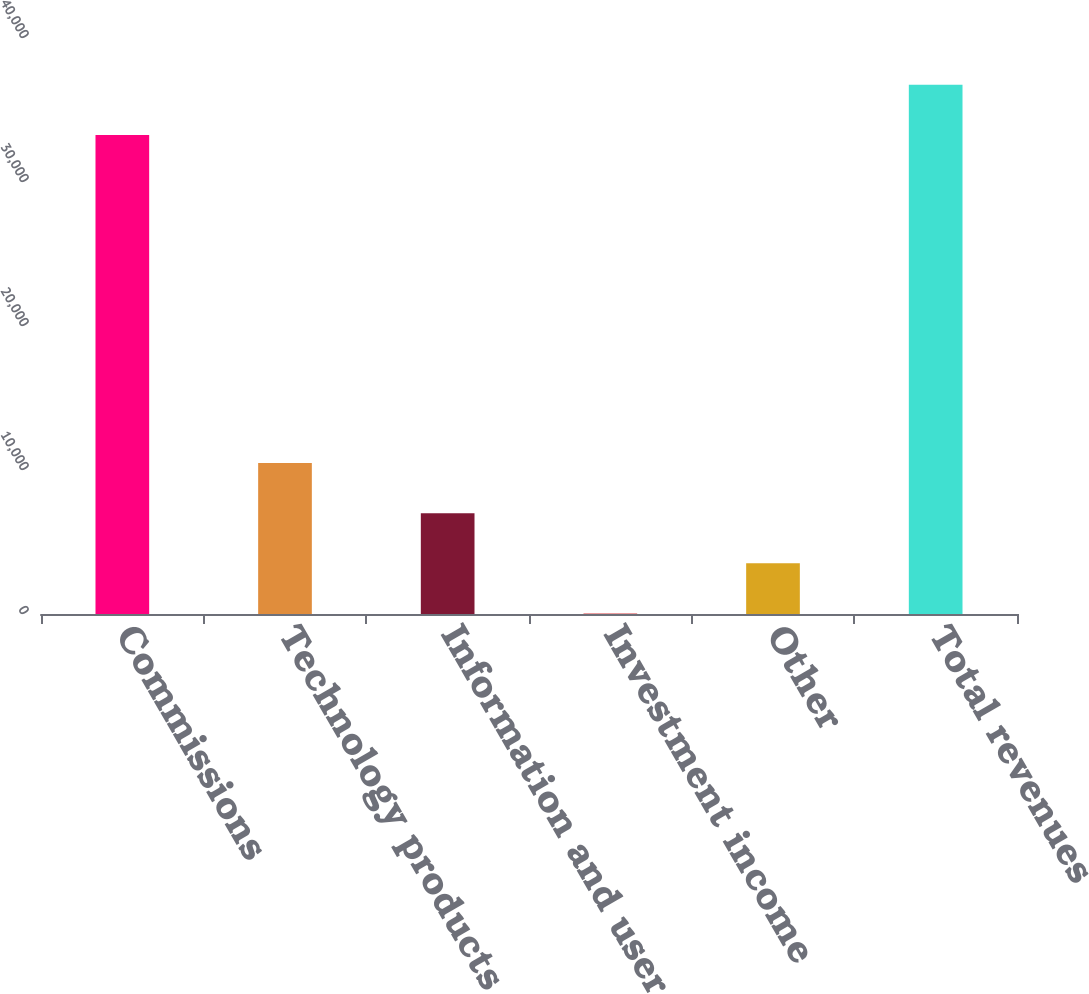Convert chart. <chart><loc_0><loc_0><loc_500><loc_500><bar_chart><fcel>Commissions<fcel>Technology products and<fcel>Information and user access<fcel>Investment income<fcel>Other<fcel>Total revenues<nl><fcel>33264<fcel>10487.2<fcel>7003.8<fcel>37<fcel>3520.4<fcel>36747.4<nl></chart> 